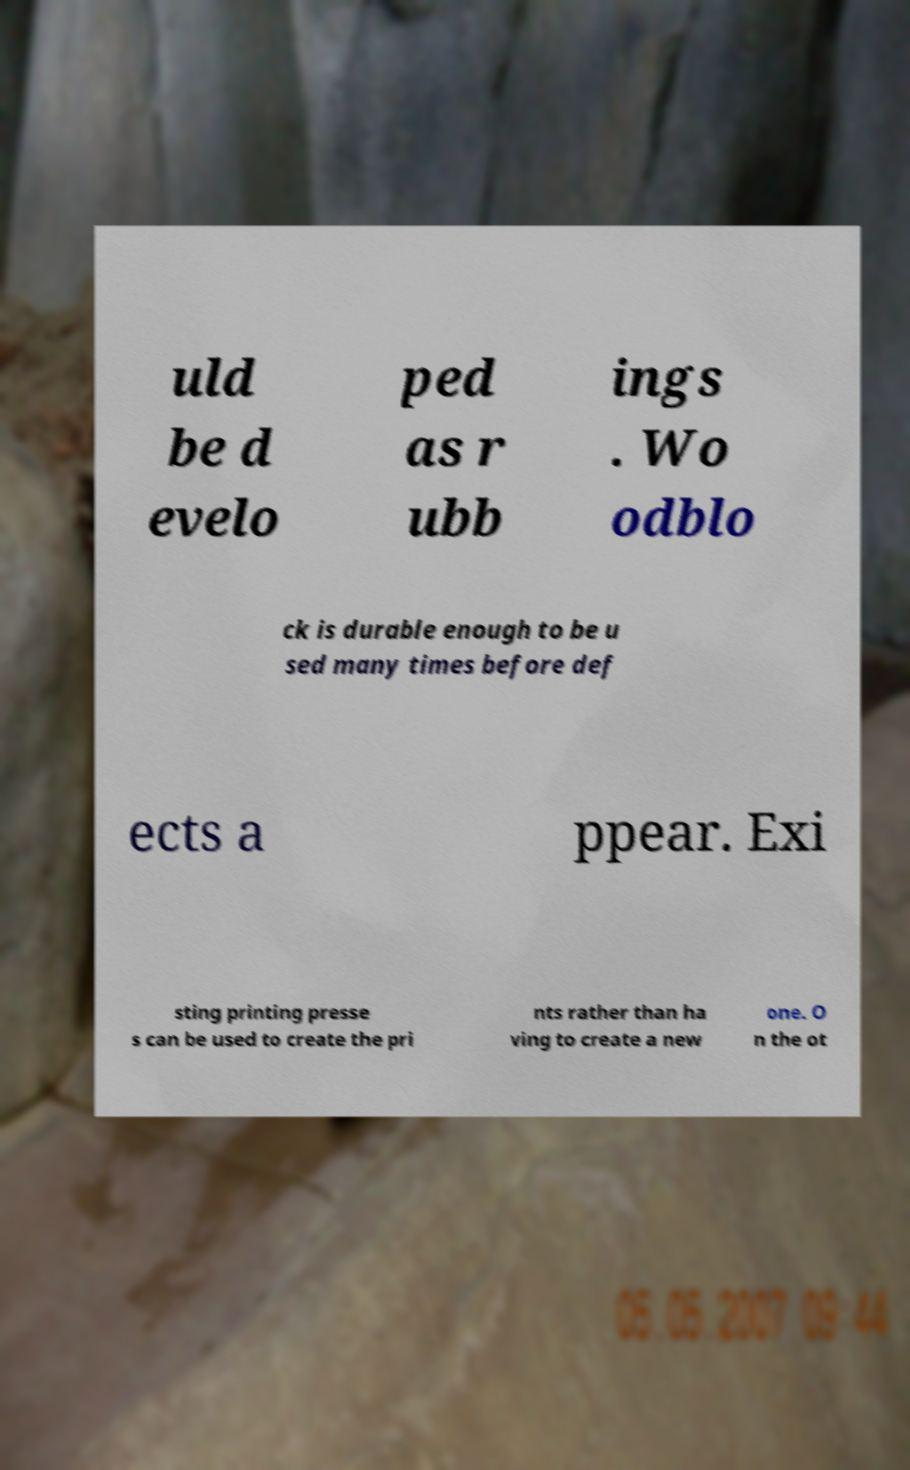Please read and relay the text visible in this image. What does it say? uld be d evelo ped as r ubb ings . Wo odblo ck is durable enough to be u sed many times before def ects a ppear. Exi sting printing presse s can be used to create the pri nts rather than ha ving to create a new one. O n the ot 